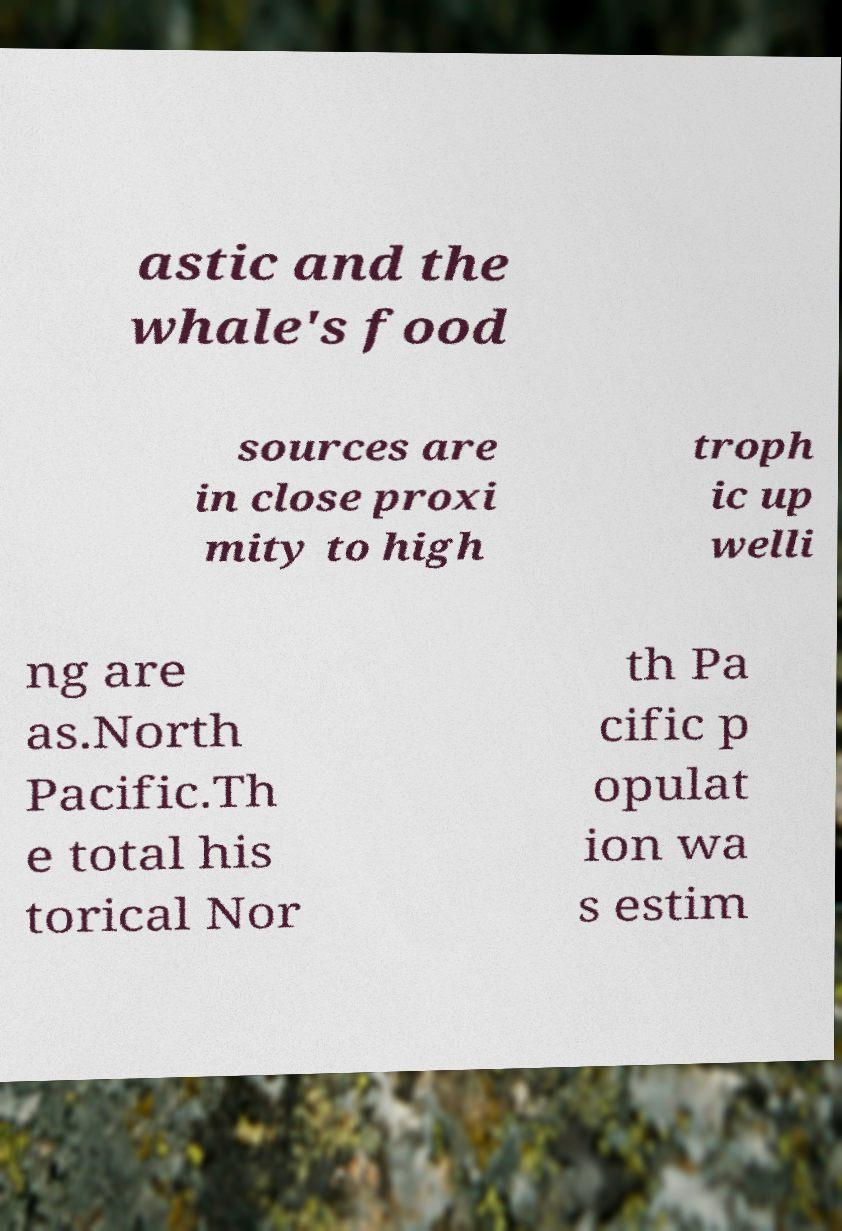For documentation purposes, I need the text within this image transcribed. Could you provide that? astic and the whale's food sources are in close proxi mity to high troph ic up welli ng are as.North Pacific.Th e total his torical Nor th Pa cific p opulat ion wa s estim 